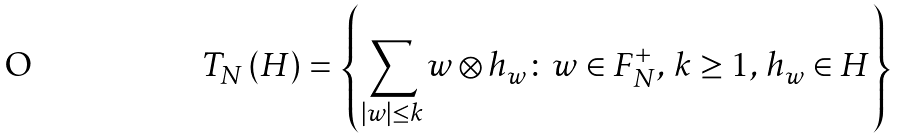Convert formula to latex. <formula><loc_0><loc_0><loc_500><loc_500>T _ { N } \left ( H \right ) = \left \{ \sum _ { \left | w \right | \leq k } w \otimes h _ { w } \colon w \in F _ { N } ^ { + } , \, k \geq 1 , \, h _ { w } \in H \right \}</formula> 